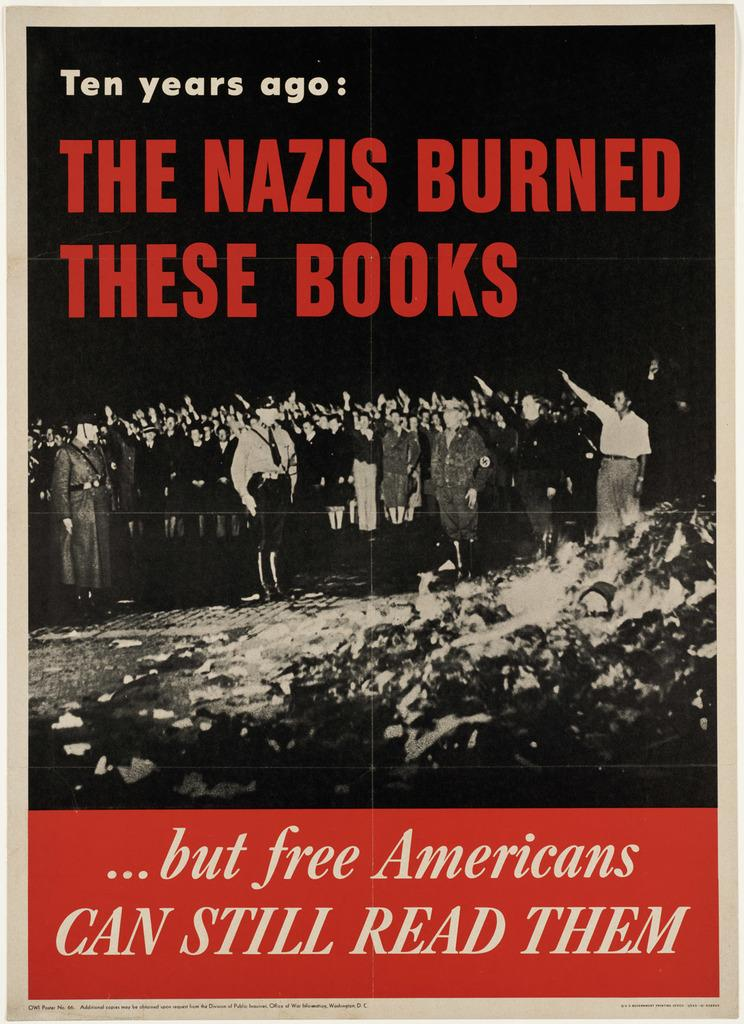Provide a one-sentence caption for the provided image. Poster or book displaying red text stating THE NAZIS BURNED THESE BOOKS. 